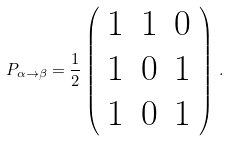Convert formula to latex. <formula><loc_0><loc_0><loc_500><loc_500>P _ { \alpha \rightarrow \beta } = \frac { 1 } { 2 } \left ( \begin{array} { c c c } 1 & 1 & 0 \\ 1 & 0 & 1 \\ 1 & 0 & 1 \end{array} \right ) \, .</formula> 